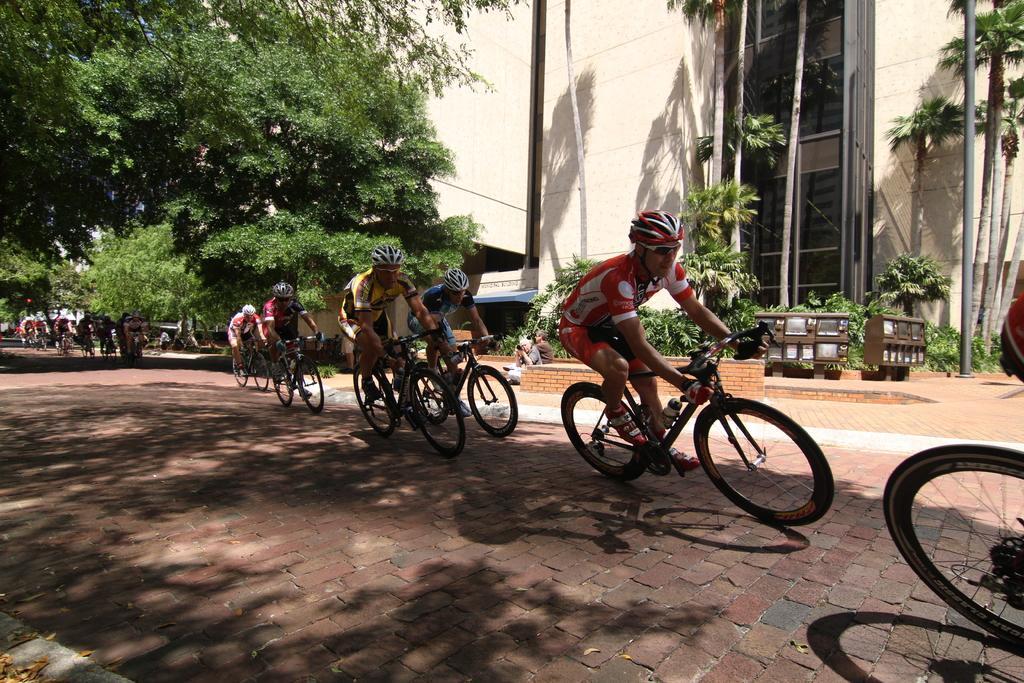Please provide a concise description of this image. In the picture we can see a road on it, we can see some people are riding bicycles, they are in sportswear and helmets and behind them, we can see some trees and plants and behind it we can see a building and near it we can see some poles. 